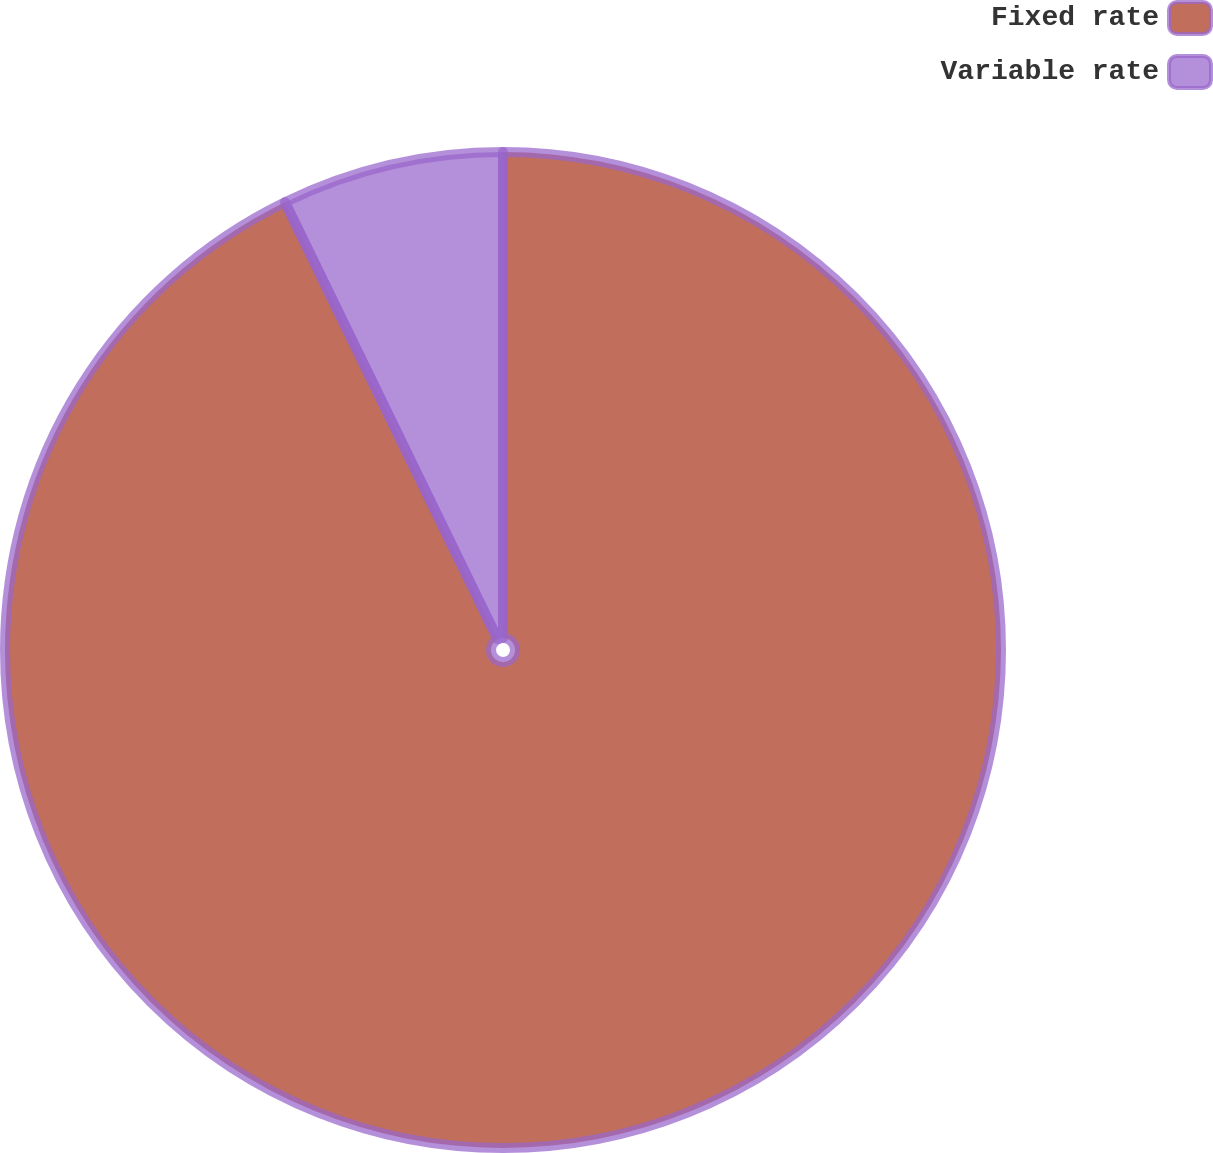Convert chart. <chart><loc_0><loc_0><loc_500><loc_500><pie_chart><fcel>Fixed rate<fcel>Variable rate<nl><fcel>92.79%<fcel>7.21%<nl></chart> 